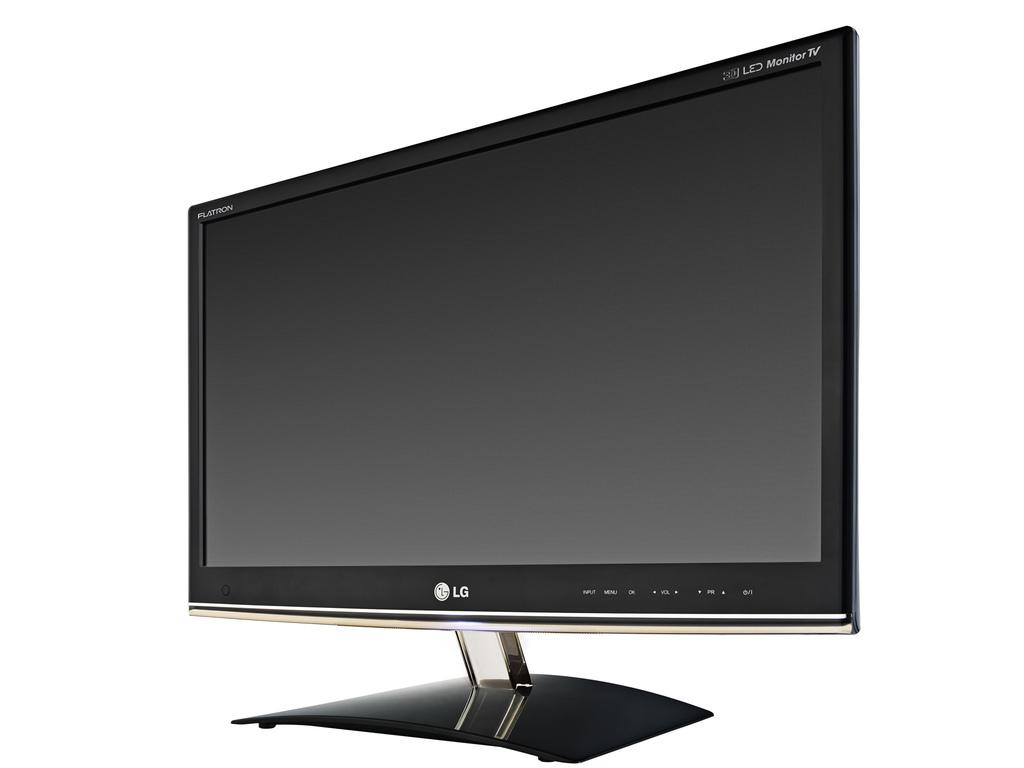What electronic device is present in the image? There is a television in the image. What is visible on the surface of the television? There is text visible on the surface of the television. How many ladybugs can be seen crawling on the television in the image? There are no ladybugs present on the television in the image. What type of division is being performed on the television in the image? There is no division being performed on the television in the image. What kind of rock is visible on the television in the image? There is no rock present on the television in the image. 